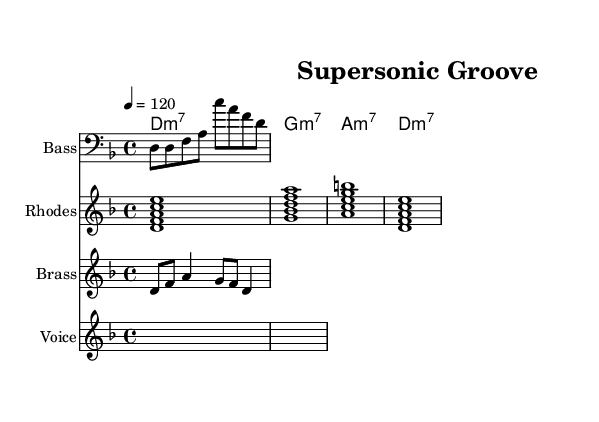What is the key signature of this music? The key signature is D minor, which consists of one flat (B flat) and is indicated at the beginning of the staff.
Answer: D minor What is the time signature of this music? The time signature is 4/4, which is shown at the beginning of the piece, indicating that there are four beats in each measure.
Answer: 4/4 What is the tempo marking for this piece? The tempo marking in the score indicates a speed of 120 beats per minute, and it is stated alongside the global music settings at the start of the score.
Answer: 120 What is the chord for the first measure of the guitar? The first measure shows a D minor 7 chord, which is indicated in the chord names at the top of the staff.
Answer: D minor 7 How many lines are in the staff for the lyrics? The voice staff contains two lines of lyrics, which consist of a verse and a chorus. Each line corresponds to a section of the song, separated by the global settings within the score.
Answer: 2 What type of musical ensemble is represented in this composition? The composition consists of a bass, Rhodes piano, brass, and voice, showcasing a typical funk ensemble structure that incorporates rhythm and harmony.
Answer: Funk ensemble What is the rhythmic structure of the bass line? The bass line features eighth notes followed by quarter notes, creating a syncopated groovy feel typical of funk music. This can be analyzed by counting the note durations provided in the notation.
Answer: Eighth and quarter notes 